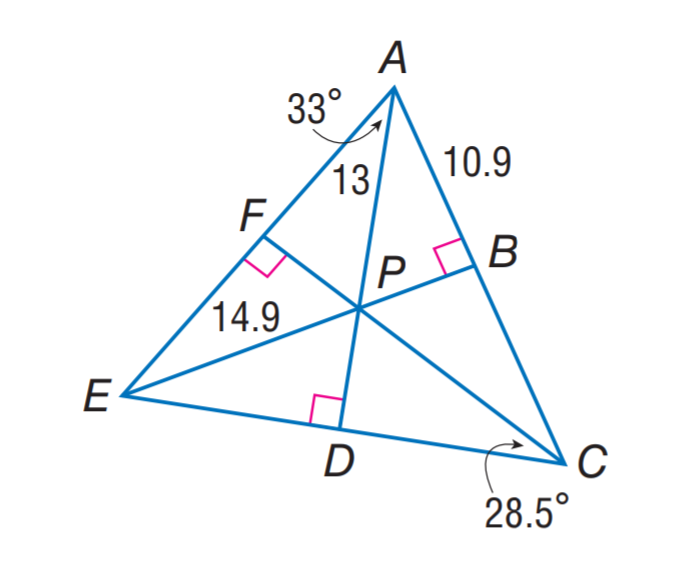Answer the mathemtical geometry problem and directly provide the correct option letter.
Question: P is the incenter of \triangle A E C. Find D E. Rounded to the nearest hundredth.
Choices: A: 13.11 B: 13.21 C: 14.90 D: 28.51 A 